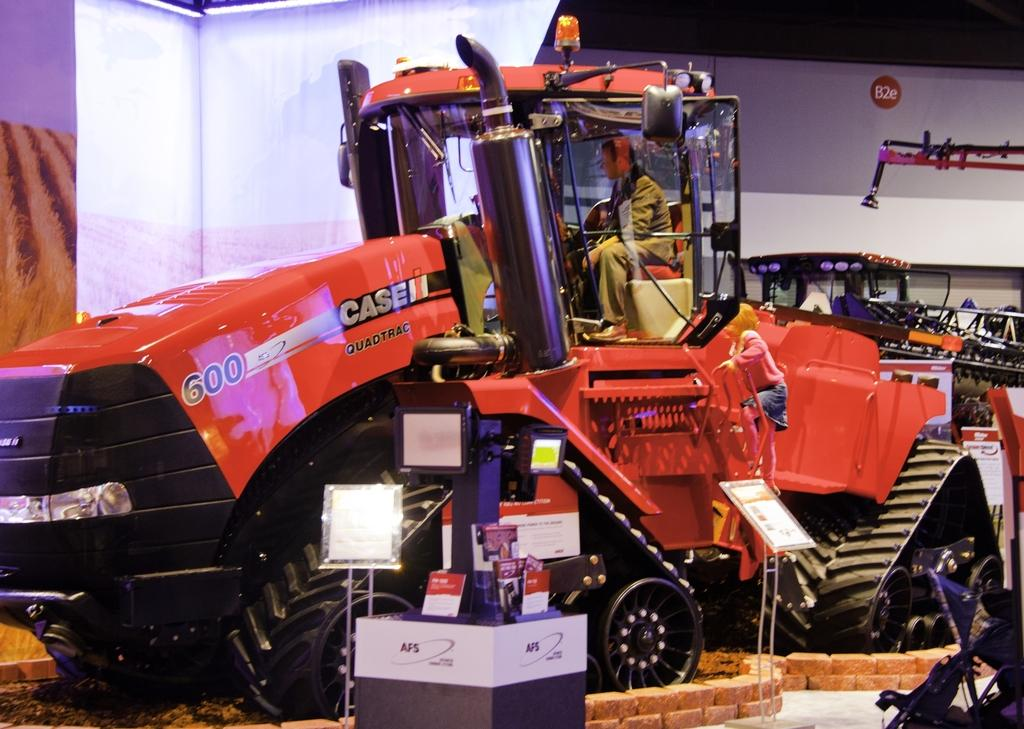What is located in the foreground of the image? There is a truck and a fence in the foreground of the image. Can you describe the person's position in the image? A person is sitting on a chair in the foreground of the image. What is visible in the background of the image? There is a wall in the background of the image. What might be the location of the image based on the provided fact? The image may have been taken at a factory outlet. What is the fuel efficiency of the truck in the image? The provided facts do not mention the fuel efficiency of the truck, so it cannot be determined from the image. What type of stew is being served at the factory outlet in the image? There is no mention of stew or any food items in the image or the provided facts. 